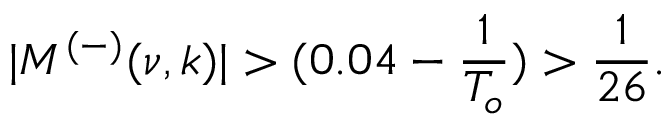Convert formula to latex. <formula><loc_0><loc_0><loc_500><loc_500>| M ^ { ( - ) } ( \nu , k ) | > ( 0 . 0 4 - \frac { 1 } { T _ { o } } ) > \frac { 1 } { 2 6 } .</formula> 